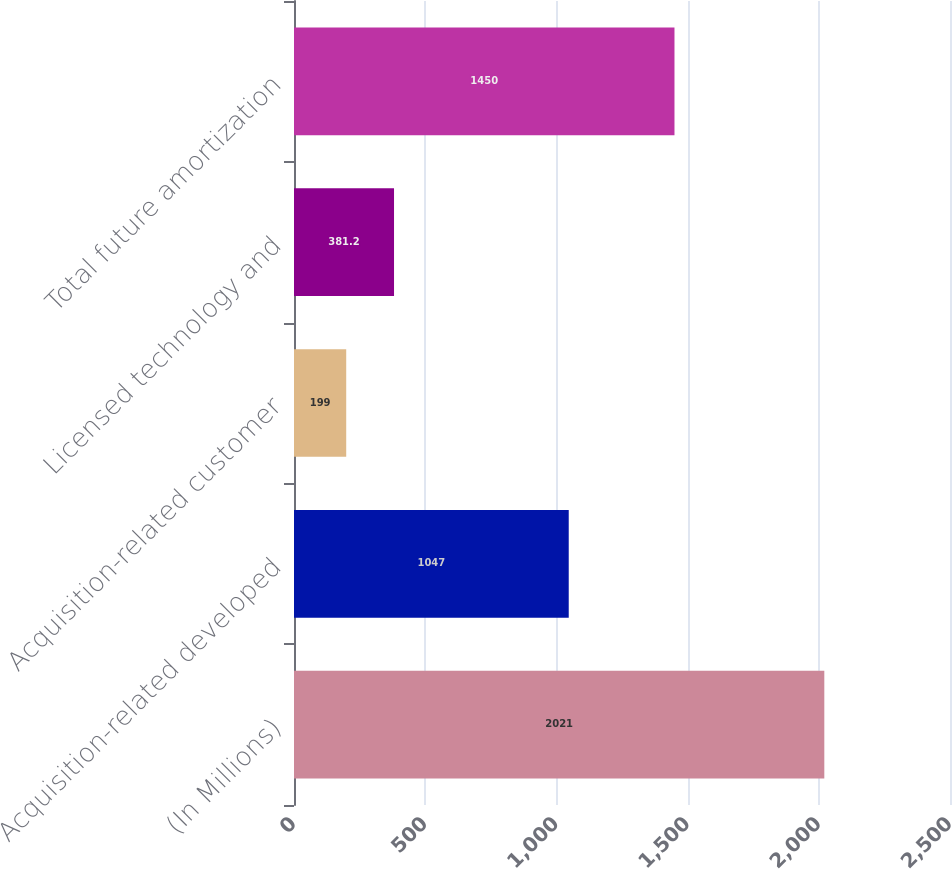Convert chart. <chart><loc_0><loc_0><loc_500><loc_500><bar_chart><fcel>(In Millions)<fcel>Acquisition-related developed<fcel>Acquisition-related customer<fcel>Licensed technology and<fcel>Total future amortization<nl><fcel>2021<fcel>1047<fcel>199<fcel>381.2<fcel>1450<nl></chart> 